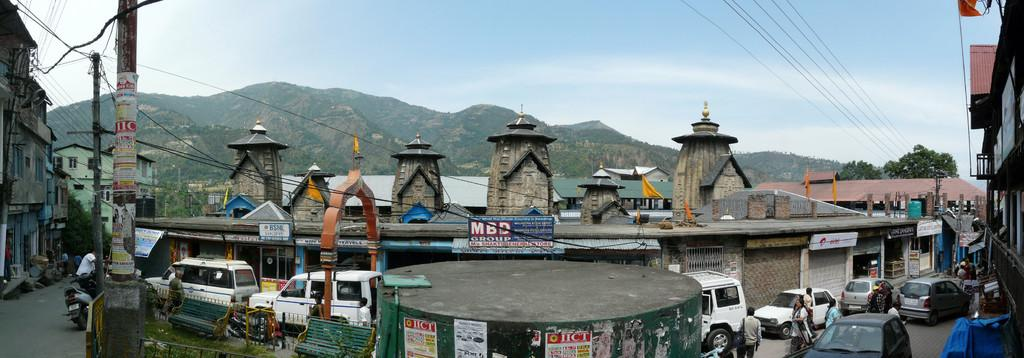What type of structures can be seen in the image? There are houses and buildings in the image. What other objects are present in the image? There are poles, vehicles, arches, and flags in the image. What letter is being used to support the arches in the image? There is no letter present in the image, and letters are not used to support the arches. Are any people wearing masks in the image? There is no indication of people or masks in the image. 